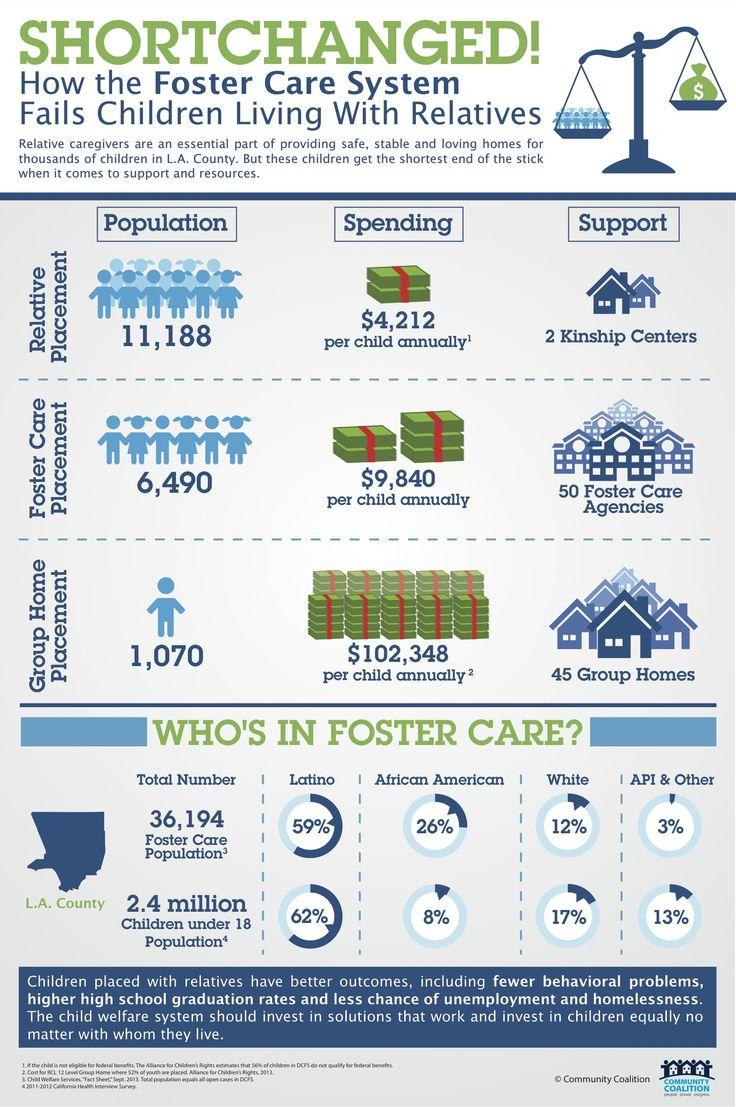Highlight a few significant elements in this photo. White people have the second lowest percentage among all racial and ethnic groups in the foster care population. Children belonging to the group of Indian, White, and Other made up the third highest number in the foster population. The group of people with the second highest percentage in the foster care population is African Americans. The cost of foster care placement is significantly higher when compared to relative placement, with a difference of 5,628. The group of children who belong to the second highest number in the foster population are those of white ethnicity. 